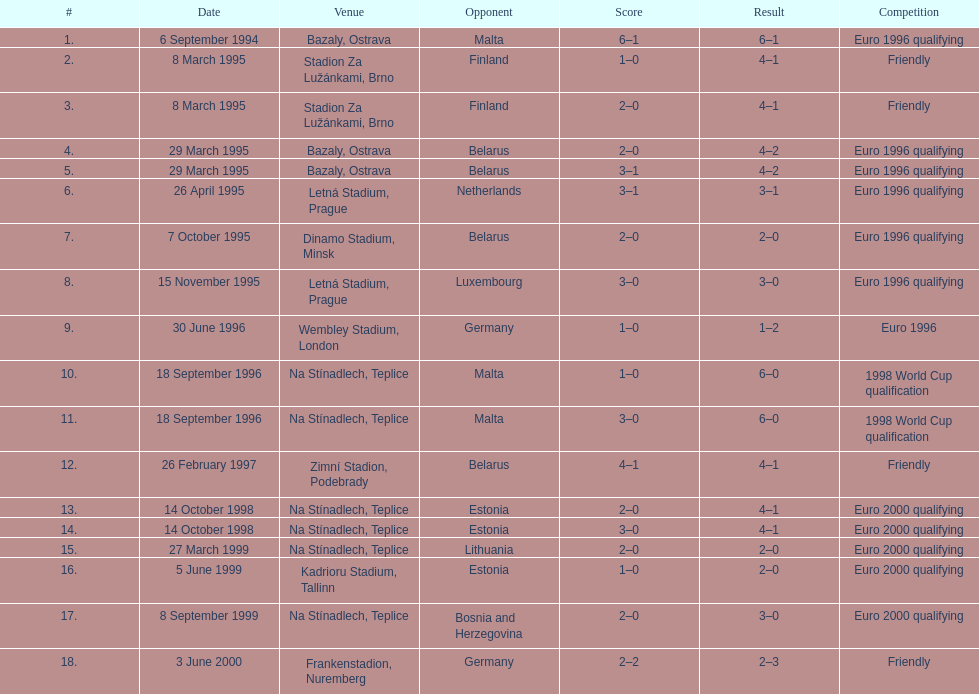What was the location used on september 18, 1996, considering that bazaly, ostrava was used on september 6, 1004? Na Stínadlech, Teplice. 